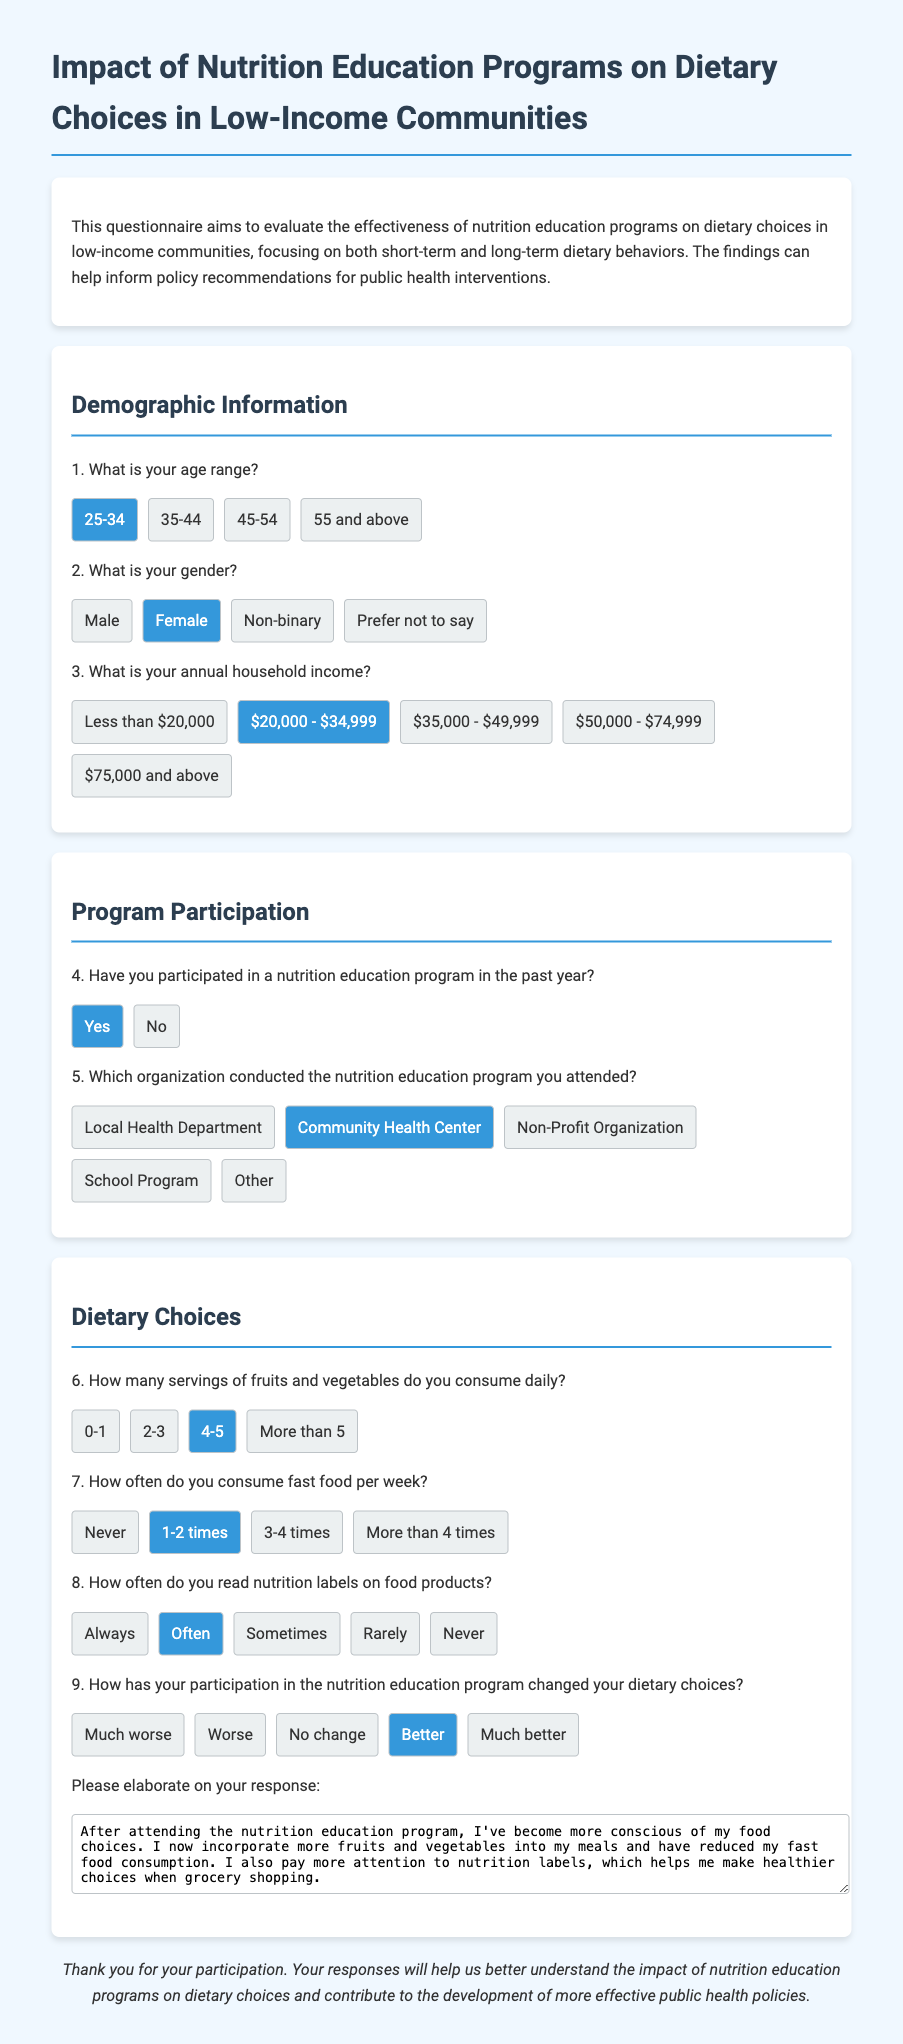What is your age range? This question asks for the age demographic of the respondent, which is specified in the demographic section of the document.
Answer: 25-34 What is your gender? This question seeks the gender identification of the participant, indicated in the demographic section.
Answer: Female What is your annual household income? This question requests information about the financial status of the respondent, found in the demographic section.
Answer: $20,000 - $34,999 Have you participated in a nutrition education program in the past year? This question determines the level of engagement with nutrition education programs among respondents, located in the program participation section.
Answer: Yes Which organization conducted the nutrition education program you attended? This question identifies the specific organization responsible for the program attended by the respondent, noted in the program participation section.
Answer: Community Health Center How many servings of fruits and vegetables do you consume daily? This question asks for the respondent's daily intake of fruits and vegetables, as discussed in the dietary choices section.
Answer: 4-5 How often do you consume fast food per week? This question addresses the frequency of fast food consumption, also found in the dietary choices section.
Answer: 1-2 times How often do you read nutrition labels on food products? This question seeks to understand the participant's habits regarding nutrition label reading, specified in the dietary choices section.
Answer: Often How has your participation in the nutrition education program changed your dietary choices? This question evaluates the perceived impact of the program on dietary behaviors, located in the dietary choices section.
Answer: Better Please elaborate on your response: This open-ended question invites the respondent to provide additional details about their dietary changes following the education program, as indicated in the final question of the dietary choices section.
Answer: After attending the nutrition education program, I've become more conscious of my food choices. I now incorporate more fruits and vegetables into my meals and have reduced my fast food consumption. I also pay more attention to nutrition labels, which helps me make healthier choices when grocery shopping 